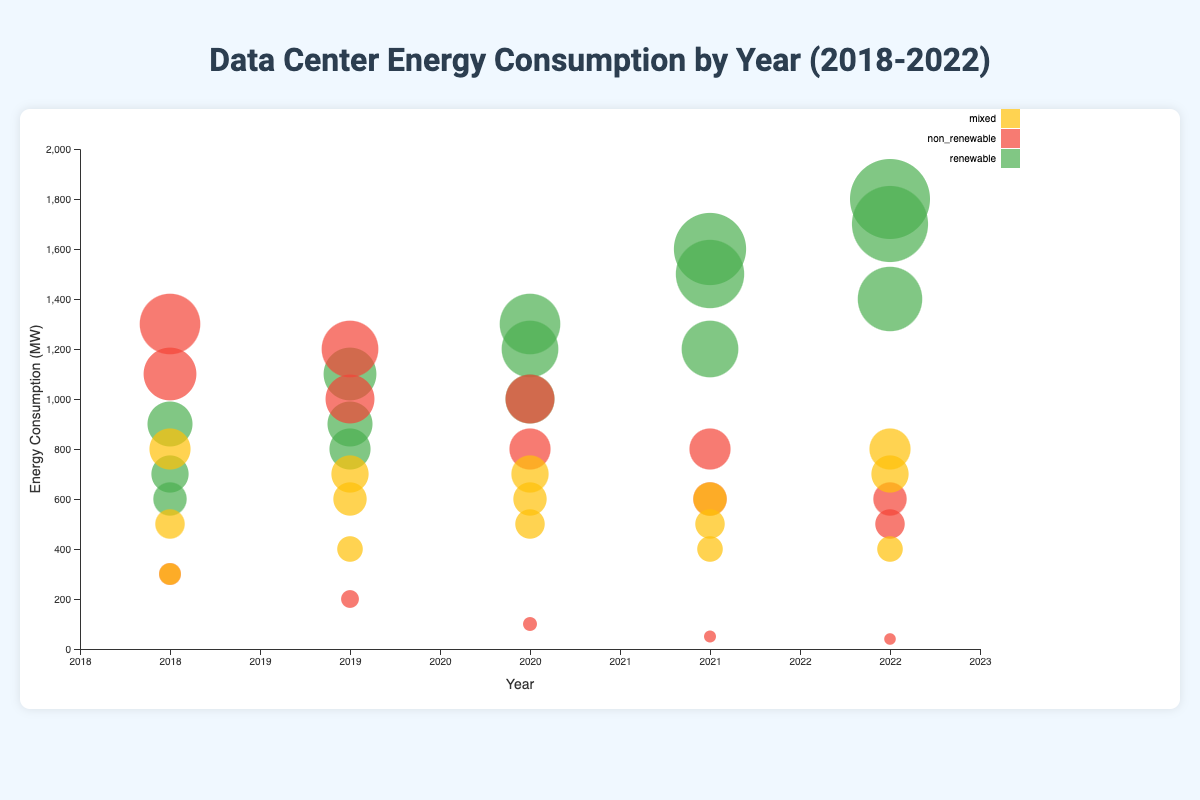What is the title of the figure? The title is prominently displayed at the top and typically summarizes the main subject of the chart. In this case, it's "Data Center Energy Consumption by Year (2018-2022)"
Answer: Data Center Energy Consumption by Year (2018-2022) Which power source has the largest bubble in the year 2022? The size of the bubble represents the power consumption in MW. The largest bubble for 2022 belongs to the "Google Council Bluffs" data center under the "renewable" category, which is 1800 MW
Answer: renewable What are the axes titles on the figure? The x-axis title mentions the time period, labeled as "Year". The y-axis title indicates the metric being measured, which is "Energy Consumption (MW)"
Answer: Year; Energy Consumption (MW) How many different data centers are represented for the year 2018? Each different data center is marked with bubbles for their power sources. In 2018, the data centers represented are AWS US-East-1, Google Iowa, and Azure Central US, which amounts to 3
Answer: 3 What is the total mixed power consumption for all data centers in 2019? The bubbles for mixed energy consumption in 2019 are AWS US-East-1 (600 MW), Google Iowa (700 MW), and Azure Central US (400 MW). Summing these up gives 600 + 700 + 400 = 1700 MW
Answer: 1700 MW Which data center shows the highest increase in renewable power consumption from 2018 to 2021? To find this, calculate the increase in renewable consumption for each data center over the period. AWS US-East-1 increased from 700 MW in 2018 to 1500 MW in 2021 (an increase of 800 MW), Google Iowa increased from 900 MW to 1600 MW (an increase of 700 MW), and Azure Central US increased from 600 MW to 1200 MW (an increase of 600 MW). AWS US-East-1 had the highest increase
Answer: AWS US-East-1 What trends can be observed in renewable power consumption from 2018 to 2022? By comparing the sizes of renewable consumption bubbles from 2018 to 2022, an upward trend is noticeable for all data centers, indicating a general increase in renewable energy consumption over the years
Answer: Increasing trend Between 2019 and 2020, which data center reduced its non-renewable energy consumption? To answer this, compare the size of non-renewable energy bubbles for each data center between 2019 and 2020. AWS US-East-1 reduced from 1200 MW in 2019 to 1000 MW in 2020, and Azure Central US reduced from 1000 MW to 800 MW. Google Iowa decreased from 200 MW to 100 MW
Answer: All three: AWS US-East-1, Google Iowa, Azure Central US How does the energy consumption of AWS US-West-1 in 2022 compare to Azure West US 2 in 2022 for mixed sources? Look at the size of the mixed source energy bubbles for both data centers in 2022. AWS US-West-1 has a mixed consumption of 800 MW, while Azure West US 2 has 700 MW, so AWS US-West-1 has a higher mixed source consumption
Answer: AWS US-West-1 has higher mixed consumption 